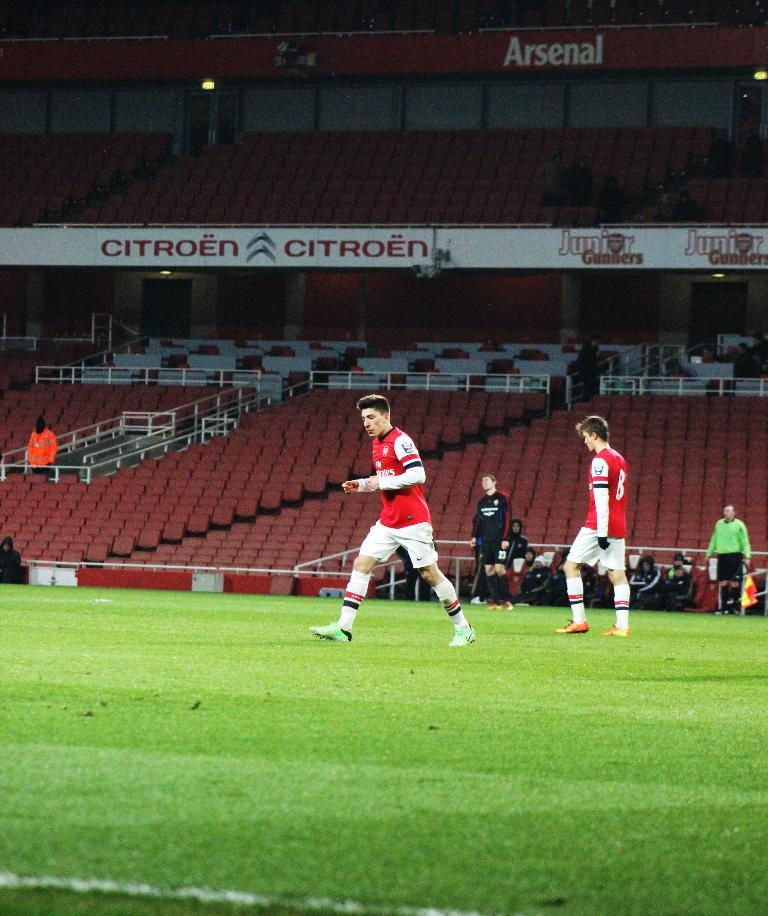<image>
Summarize the visual content of the image. Soccer players are on the field with a Citroen advertisement in the background. 